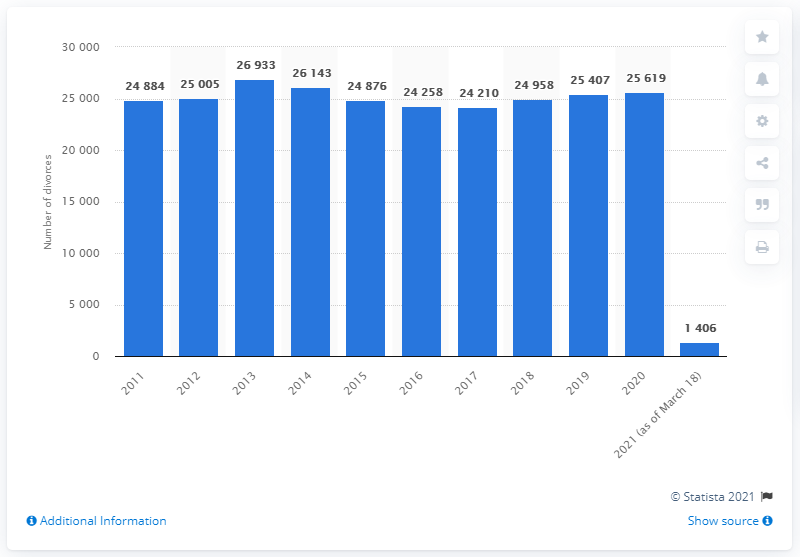Draw attention to some important aspects in this diagram. The peak number of divorces in Sweden was recorded in 2013. As of 2020, there were approximately 25,619 divorces in Sweden. The number of divorces increased again in 2018. In 2013, a total of 26,933 couples in Sweden got divorced. 